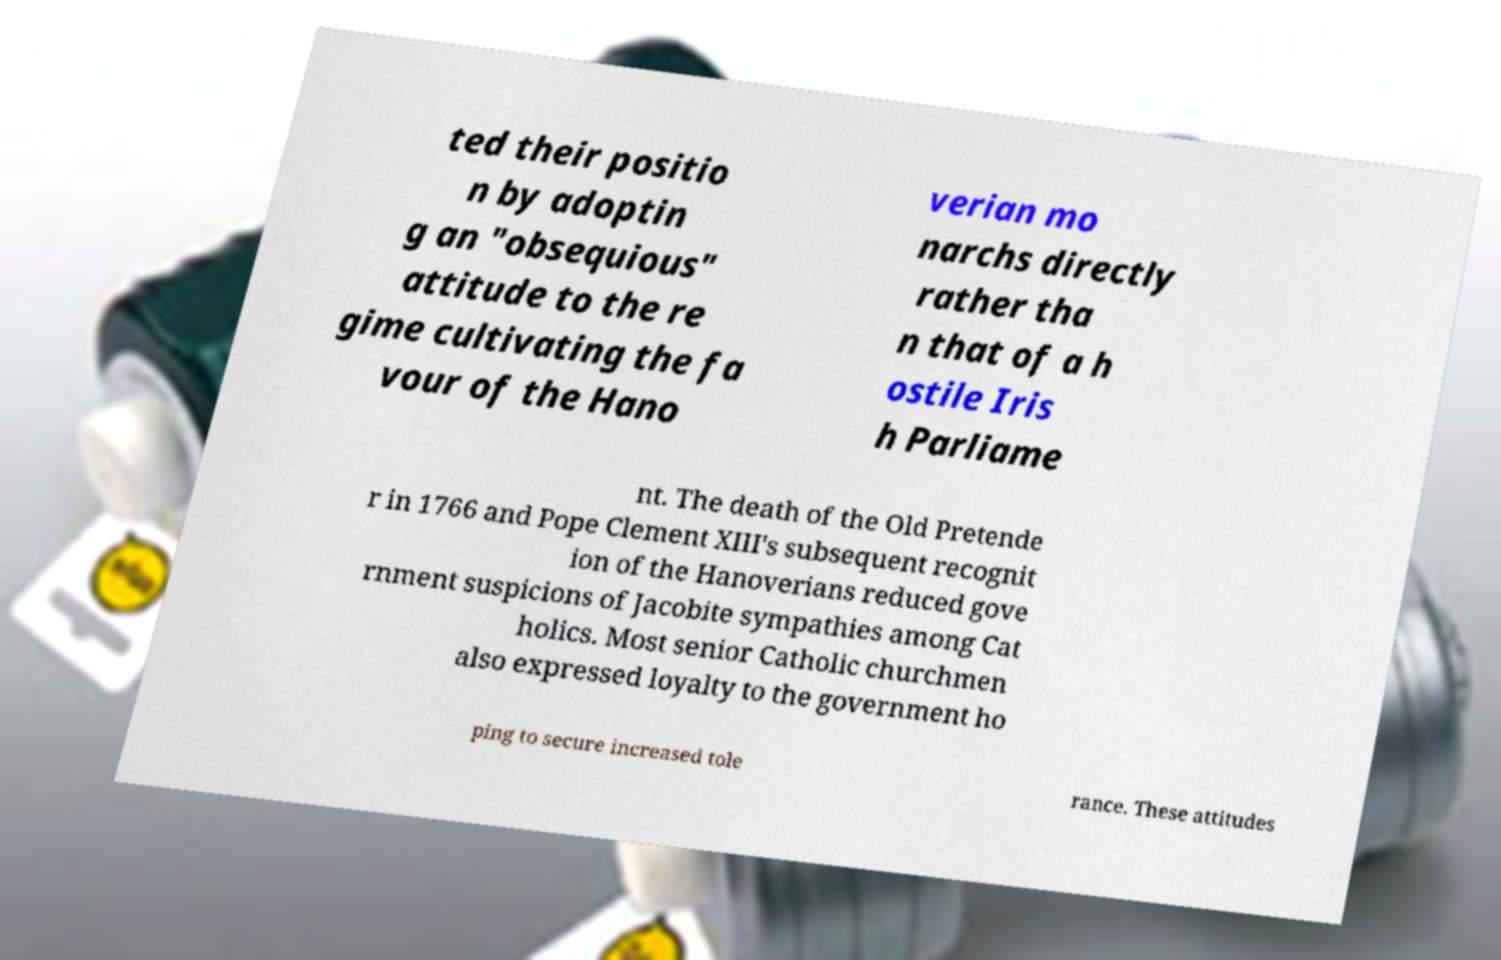Please identify and transcribe the text found in this image. ted their positio n by adoptin g an "obsequious" attitude to the re gime cultivating the fa vour of the Hano verian mo narchs directly rather tha n that of a h ostile Iris h Parliame nt. The death of the Old Pretende r in 1766 and Pope Clement XIII's subsequent recognit ion of the Hanoverians reduced gove rnment suspicions of Jacobite sympathies among Cat holics. Most senior Catholic churchmen also expressed loyalty to the government ho ping to secure increased tole rance. These attitudes 